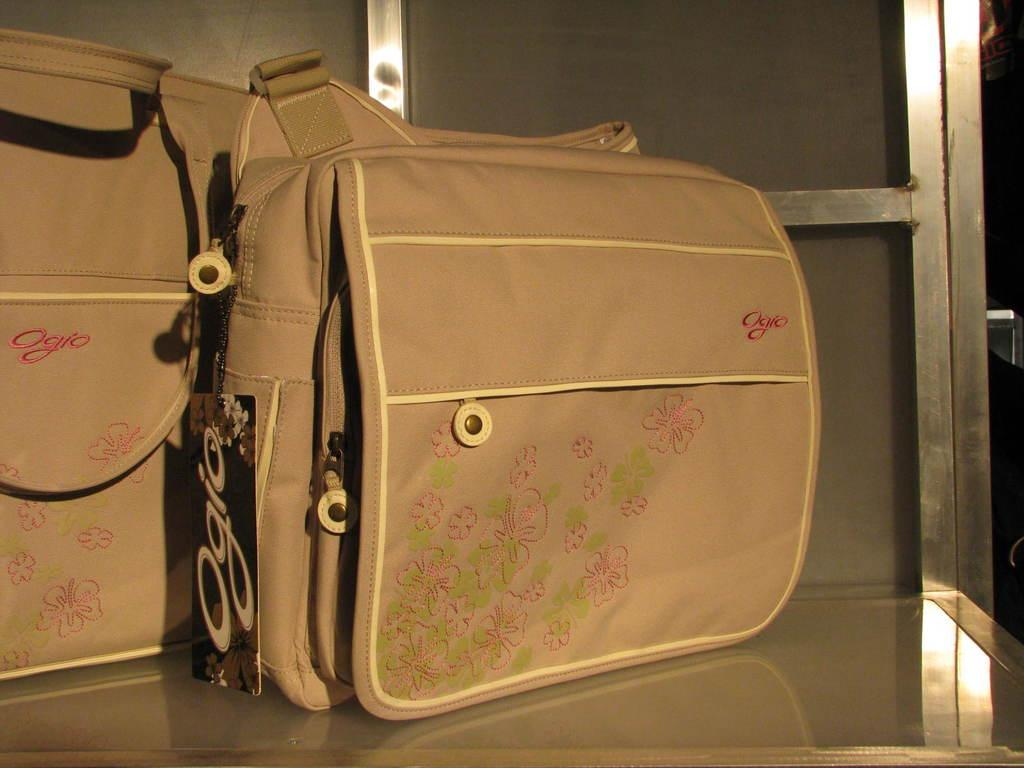How many bags can be seen in the image? There are two bags in the image. What is the color of the bags? Both bags are brown in color. Is there a letter addressed to hope in one of the bags? There is no information about letters or the contents of the bags in the provided facts, so we cannot determine if there is a letter addressed to hope in one of the bags. 